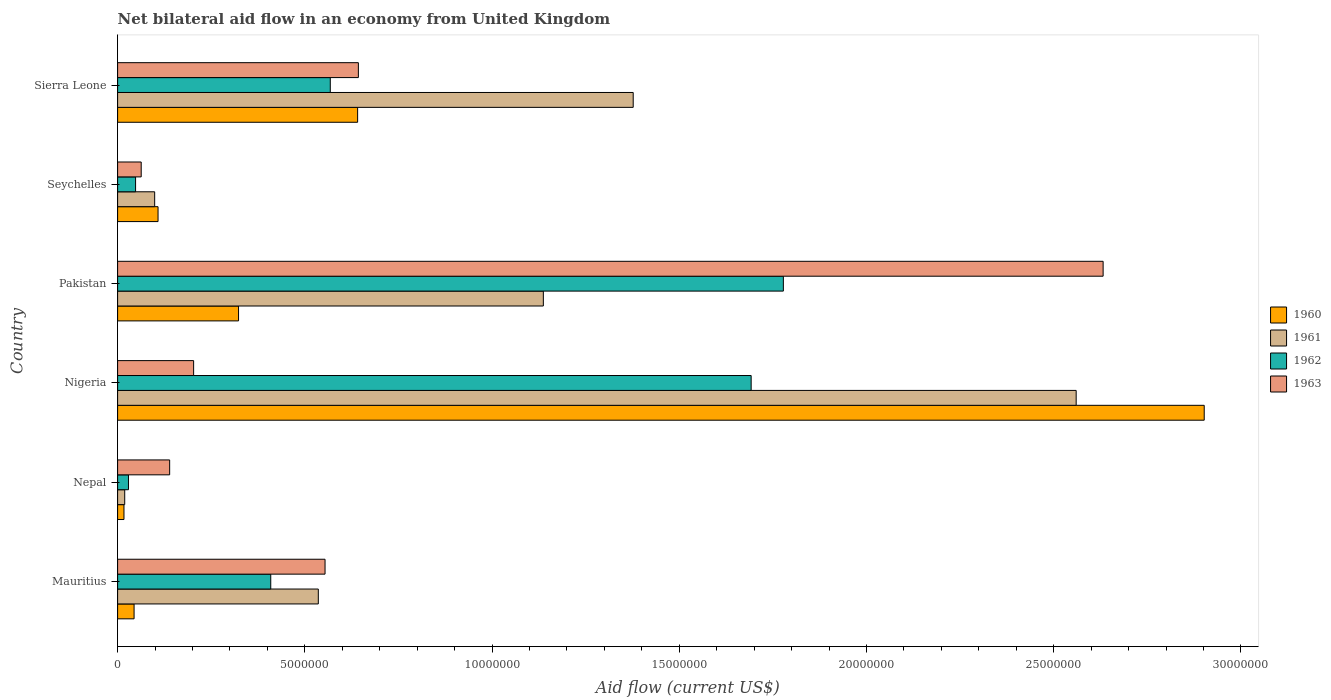Are the number of bars per tick equal to the number of legend labels?
Your answer should be compact. Yes. How many bars are there on the 3rd tick from the top?
Offer a terse response. 4. What is the label of the 2nd group of bars from the top?
Your response must be concise. Seychelles. Across all countries, what is the maximum net bilateral aid flow in 1962?
Keep it short and to the point. 1.78e+07. In which country was the net bilateral aid flow in 1962 maximum?
Provide a succinct answer. Pakistan. In which country was the net bilateral aid flow in 1962 minimum?
Your answer should be very brief. Nepal. What is the total net bilateral aid flow in 1961 in the graph?
Ensure brevity in your answer.  5.73e+07. What is the difference between the net bilateral aid flow in 1963 in Nigeria and that in Seychelles?
Provide a succinct answer. 1.40e+06. What is the difference between the net bilateral aid flow in 1962 in Sierra Leone and the net bilateral aid flow in 1963 in Pakistan?
Offer a terse response. -2.06e+07. What is the average net bilateral aid flow in 1963 per country?
Your answer should be very brief. 7.06e+06. What is the difference between the net bilateral aid flow in 1962 and net bilateral aid flow in 1963 in Pakistan?
Offer a very short reply. -8.54e+06. In how many countries, is the net bilateral aid flow in 1960 greater than 25000000 US$?
Offer a very short reply. 1. What is the ratio of the net bilateral aid flow in 1960 in Pakistan to that in Seychelles?
Keep it short and to the point. 2.99. Is the difference between the net bilateral aid flow in 1962 in Nepal and Pakistan greater than the difference between the net bilateral aid flow in 1963 in Nepal and Pakistan?
Provide a succinct answer. Yes. What is the difference between the highest and the second highest net bilateral aid flow in 1963?
Keep it short and to the point. 1.99e+07. What is the difference between the highest and the lowest net bilateral aid flow in 1962?
Ensure brevity in your answer.  1.75e+07. Is the sum of the net bilateral aid flow in 1960 in Nepal and Seychelles greater than the maximum net bilateral aid flow in 1961 across all countries?
Your answer should be very brief. No. Is it the case that in every country, the sum of the net bilateral aid flow in 1961 and net bilateral aid flow in 1962 is greater than the sum of net bilateral aid flow in 1960 and net bilateral aid flow in 1963?
Keep it short and to the point. No. What does the 3rd bar from the bottom in Sierra Leone represents?
Your answer should be very brief. 1962. Is it the case that in every country, the sum of the net bilateral aid flow in 1960 and net bilateral aid flow in 1961 is greater than the net bilateral aid flow in 1962?
Provide a short and direct response. No. How many bars are there?
Make the answer very short. 24. Are the values on the major ticks of X-axis written in scientific E-notation?
Provide a succinct answer. No. Does the graph contain any zero values?
Make the answer very short. No. Does the graph contain grids?
Provide a succinct answer. No. Where does the legend appear in the graph?
Your answer should be compact. Center right. How many legend labels are there?
Offer a terse response. 4. How are the legend labels stacked?
Your answer should be compact. Vertical. What is the title of the graph?
Your response must be concise. Net bilateral aid flow in an economy from United Kingdom. What is the Aid flow (current US$) in 1961 in Mauritius?
Your response must be concise. 5.36e+06. What is the Aid flow (current US$) in 1962 in Mauritius?
Your answer should be compact. 4.09e+06. What is the Aid flow (current US$) in 1963 in Mauritius?
Provide a succinct answer. 5.54e+06. What is the Aid flow (current US$) of 1961 in Nepal?
Your answer should be compact. 1.90e+05. What is the Aid flow (current US$) in 1962 in Nepal?
Offer a very short reply. 2.90e+05. What is the Aid flow (current US$) in 1963 in Nepal?
Give a very brief answer. 1.39e+06. What is the Aid flow (current US$) of 1960 in Nigeria?
Give a very brief answer. 2.90e+07. What is the Aid flow (current US$) of 1961 in Nigeria?
Keep it short and to the point. 2.56e+07. What is the Aid flow (current US$) in 1962 in Nigeria?
Your answer should be very brief. 1.69e+07. What is the Aid flow (current US$) in 1963 in Nigeria?
Your response must be concise. 2.03e+06. What is the Aid flow (current US$) in 1960 in Pakistan?
Your response must be concise. 3.23e+06. What is the Aid flow (current US$) of 1961 in Pakistan?
Keep it short and to the point. 1.14e+07. What is the Aid flow (current US$) of 1962 in Pakistan?
Your response must be concise. 1.78e+07. What is the Aid flow (current US$) in 1963 in Pakistan?
Ensure brevity in your answer.  2.63e+07. What is the Aid flow (current US$) in 1960 in Seychelles?
Ensure brevity in your answer.  1.08e+06. What is the Aid flow (current US$) of 1961 in Seychelles?
Provide a succinct answer. 9.90e+05. What is the Aid flow (current US$) in 1963 in Seychelles?
Your answer should be very brief. 6.30e+05. What is the Aid flow (current US$) in 1960 in Sierra Leone?
Your answer should be very brief. 6.41e+06. What is the Aid flow (current US$) of 1961 in Sierra Leone?
Provide a succinct answer. 1.38e+07. What is the Aid flow (current US$) of 1962 in Sierra Leone?
Your answer should be compact. 5.68e+06. What is the Aid flow (current US$) of 1963 in Sierra Leone?
Ensure brevity in your answer.  6.43e+06. Across all countries, what is the maximum Aid flow (current US$) of 1960?
Make the answer very short. 2.90e+07. Across all countries, what is the maximum Aid flow (current US$) of 1961?
Keep it short and to the point. 2.56e+07. Across all countries, what is the maximum Aid flow (current US$) in 1962?
Ensure brevity in your answer.  1.78e+07. Across all countries, what is the maximum Aid flow (current US$) in 1963?
Your answer should be compact. 2.63e+07. Across all countries, what is the minimum Aid flow (current US$) in 1961?
Make the answer very short. 1.90e+05. Across all countries, what is the minimum Aid flow (current US$) in 1962?
Offer a terse response. 2.90e+05. Across all countries, what is the minimum Aid flow (current US$) in 1963?
Keep it short and to the point. 6.30e+05. What is the total Aid flow (current US$) in 1960 in the graph?
Your answer should be very brief. 4.04e+07. What is the total Aid flow (current US$) in 1961 in the graph?
Make the answer very short. 5.73e+07. What is the total Aid flow (current US$) in 1962 in the graph?
Offer a very short reply. 4.52e+07. What is the total Aid flow (current US$) of 1963 in the graph?
Ensure brevity in your answer.  4.23e+07. What is the difference between the Aid flow (current US$) of 1960 in Mauritius and that in Nepal?
Provide a succinct answer. 2.70e+05. What is the difference between the Aid flow (current US$) of 1961 in Mauritius and that in Nepal?
Your answer should be very brief. 5.17e+06. What is the difference between the Aid flow (current US$) in 1962 in Mauritius and that in Nepal?
Ensure brevity in your answer.  3.80e+06. What is the difference between the Aid flow (current US$) of 1963 in Mauritius and that in Nepal?
Make the answer very short. 4.15e+06. What is the difference between the Aid flow (current US$) of 1960 in Mauritius and that in Nigeria?
Your answer should be compact. -2.86e+07. What is the difference between the Aid flow (current US$) of 1961 in Mauritius and that in Nigeria?
Provide a short and direct response. -2.02e+07. What is the difference between the Aid flow (current US$) in 1962 in Mauritius and that in Nigeria?
Give a very brief answer. -1.28e+07. What is the difference between the Aid flow (current US$) of 1963 in Mauritius and that in Nigeria?
Keep it short and to the point. 3.51e+06. What is the difference between the Aid flow (current US$) in 1960 in Mauritius and that in Pakistan?
Your answer should be compact. -2.79e+06. What is the difference between the Aid flow (current US$) in 1961 in Mauritius and that in Pakistan?
Your answer should be very brief. -6.01e+06. What is the difference between the Aid flow (current US$) of 1962 in Mauritius and that in Pakistan?
Make the answer very short. -1.37e+07. What is the difference between the Aid flow (current US$) of 1963 in Mauritius and that in Pakistan?
Your response must be concise. -2.08e+07. What is the difference between the Aid flow (current US$) in 1960 in Mauritius and that in Seychelles?
Provide a short and direct response. -6.40e+05. What is the difference between the Aid flow (current US$) in 1961 in Mauritius and that in Seychelles?
Ensure brevity in your answer.  4.37e+06. What is the difference between the Aid flow (current US$) in 1962 in Mauritius and that in Seychelles?
Keep it short and to the point. 3.61e+06. What is the difference between the Aid flow (current US$) in 1963 in Mauritius and that in Seychelles?
Make the answer very short. 4.91e+06. What is the difference between the Aid flow (current US$) in 1960 in Mauritius and that in Sierra Leone?
Your response must be concise. -5.97e+06. What is the difference between the Aid flow (current US$) in 1961 in Mauritius and that in Sierra Leone?
Your response must be concise. -8.41e+06. What is the difference between the Aid flow (current US$) of 1962 in Mauritius and that in Sierra Leone?
Your response must be concise. -1.59e+06. What is the difference between the Aid flow (current US$) in 1963 in Mauritius and that in Sierra Leone?
Offer a terse response. -8.90e+05. What is the difference between the Aid flow (current US$) in 1960 in Nepal and that in Nigeria?
Your response must be concise. -2.88e+07. What is the difference between the Aid flow (current US$) in 1961 in Nepal and that in Nigeria?
Ensure brevity in your answer.  -2.54e+07. What is the difference between the Aid flow (current US$) in 1962 in Nepal and that in Nigeria?
Keep it short and to the point. -1.66e+07. What is the difference between the Aid flow (current US$) in 1963 in Nepal and that in Nigeria?
Your answer should be very brief. -6.40e+05. What is the difference between the Aid flow (current US$) in 1960 in Nepal and that in Pakistan?
Give a very brief answer. -3.06e+06. What is the difference between the Aid flow (current US$) of 1961 in Nepal and that in Pakistan?
Keep it short and to the point. -1.12e+07. What is the difference between the Aid flow (current US$) of 1962 in Nepal and that in Pakistan?
Offer a terse response. -1.75e+07. What is the difference between the Aid flow (current US$) in 1963 in Nepal and that in Pakistan?
Provide a succinct answer. -2.49e+07. What is the difference between the Aid flow (current US$) in 1960 in Nepal and that in Seychelles?
Keep it short and to the point. -9.10e+05. What is the difference between the Aid flow (current US$) of 1961 in Nepal and that in Seychelles?
Offer a very short reply. -8.00e+05. What is the difference between the Aid flow (current US$) of 1962 in Nepal and that in Seychelles?
Your answer should be compact. -1.90e+05. What is the difference between the Aid flow (current US$) of 1963 in Nepal and that in Seychelles?
Provide a succinct answer. 7.60e+05. What is the difference between the Aid flow (current US$) in 1960 in Nepal and that in Sierra Leone?
Keep it short and to the point. -6.24e+06. What is the difference between the Aid flow (current US$) of 1961 in Nepal and that in Sierra Leone?
Provide a succinct answer. -1.36e+07. What is the difference between the Aid flow (current US$) in 1962 in Nepal and that in Sierra Leone?
Your response must be concise. -5.39e+06. What is the difference between the Aid flow (current US$) of 1963 in Nepal and that in Sierra Leone?
Make the answer very short. -5.04e+06. What is the difference between the Aid flow (current US$) in 1960 in Nigeria and that in Pakistan?
Ensure brevity in your answer.  2.58e+07. What is the difference between the Aid flow (current US$) of 1961 in Nigeria and that in Pakistan?
Offer a very short reply. 1.42e+07. What is the difference between the Aid flow (current US$) of 1962 in Nigeria and that in Pakistan?
Provide a short and direct response. -8.60e+05. What is the difference between the Aid flow (current US$) of 1963 in Nigeria and that in Pakistan?
Ensure brevity in your answer.  -2.43e+07. What is the difference between the Aid flow (current US$) in 1960 in Nigeria and that in Seychelles?
Ensure brevity in your answer.  2.79e+07. What is the difference between the Aid flow (current US$) in 1961 in Nigeria and that in Seychelles?
Keep it short and to the point. 2.46e+07. What is the difference between the Aid flow (current US$) of 1962 in Nigeria and that in Seychelles?
Your answer should be compact. 1.64e+07. What is the difference between the Aid flow (current US$) in 1963 in Nigeria and that in Seychelles?
Your answer should be compact. 1.40e+06. What is the difference between the Aid flow (current US$) in 1960 in Nigeria and that in Sierra Leone?
Your response must be concise. 2.26e+07. What is the difference between the Aid flow (current US$) of 1961 in Nigeria and that in Sierra Leone?
Give a very brief answer. 1.18e+07. What is the difference between the Aid flow (current US$) of 1962 in Nigeria and that in Sierra Leone?
Your answer should be compact. 1.12e+07. What is the difference between the Aid flow (current US$) in 1963 in Nigeria and that in Sierra Leone?
Offer a terse response. -4.40e+06. What is the difference between the Aid flow (current US$) in 1960 in Pakistan and that in Seychelles?
Give a very brief answer. 2.15e+06. What is the difference between the Aid flow (current US$) of 1961 in Pakistan and that in Seychelles?
Give a very brief answer. 1.04e+07. What is the difference between the Aid flow (current US$) of 1962 in Pakistan and that in Seychelles?
Ensure brevity in your answer.  1.73e+07. What is the difference between the Aid flow (current US$) in 1963 in Pakistan and that in Seychelles?
Provide a short and direct response. 2.57e+07. What is the difference between the Aid flow (current US$) of 1960 in Pakistan and that in Sierra Leone?
Give a very brief answer. -3.18e+06. What is the difference between the Aid flow (current US$) of 1961 in Pakistan and that in Sierra Leone?
Offer a terse response. -2.40e+06. What is the difference between the Aid flow (current US$) of 1962 in Pakistan and that in Sierra Leone?
Provide a short and direct response. 1.21e+07. What is the difference between the Aid flow (current US$) of 1963 in Pakistan and that in Sierra Leone?
Provide a succinct answer. 1.99e+07. What is the difference between the Aid flow (current US$) in 1960 in Seychelles and that in Sierra Leone?
Make the answer very short. -5.33e+06. What is the difference between the Aid flow (current US$) in 1961 in Seychelles and that in Sierra Leone?
Your answer should be very brief. -1.28e+07. What is the difference between the Aid flow (current US$) in 1962 in Seychelles and that in Sierra Leone?
Keep it short and to the point. -5.20e+06. What is the difference between the Aid flow (current US$) in 1963 in Seychelles and that in Sierra Leone?
Keep it short and to the point. -5.80e+06. What is the difference between the Aid flow (current US$) in 1960 in Mauritius and the Aid flow (current US$) in 1963 in Nepal?
Provide a succinct answer. -9.50e+05. What is the difference between the Aid flow (current US$) of 1961 in Mauritius and the Aid flow (current US$) of 1962 in Nepal?
Your answer should be very brief. 5.07e+06. What is the difference between the Aid flow (current US$) in 1961 in Mauritius and the Aid flow (current US$) in 1963 in Nepal?
Offer a terse response. 3.97e+06. What is the difference between the Aid flow (current US$) of 1962 in Mauritius and the Aid flow (current US$) of 1963 in Nepal?
Your answer should be compact. 2.70e+06. What is the difference between the Aid flow (current US$) in 1960 in Mauritius and the Aid flow (current US$) in 1961 in Nigeria?
Offer a terse response. -2.52e+07. What is the difference between the Aid flow (current US$) in 1960 in Mauritius and the Aid flow (current US$) in 1962 in Nigeria?
Offer a terse response. -1.65e+07. What is the difference between the Aid flow (current US$) in 1960 in Mauritius and the Aid flow (current US$) in 1963 in Nigeria?
Keep it short and to the point. -1.59e+06. What is the difference between the Aid flow (current US$) of 1961 in Mauritius and the Aid flow (current US$) of 1962 in Nigeria?
Offer a terse response. -1.16e+07. What is the difference between the Aid flow (current US$) of 1961 in Mauritius and the Aid flow (current US$) of 1963 in Nigeria?
Offer a terse response. 3.33e+06. What is the difference between the Aid flow (current US$) in 1962 in Mauritius and the Aid flow (current US$) in 1963 in Nigeria?
Provide a short and direct response. 2.06e+06. What is the difference between the Aid flow (current US$) in 1960 in Mauritius and the Aid flow (current US$) in 1961 in Pakistan?
Your answer should be compact. -1.09e+07. What is the difference between the Aid flow (current US$) in 1960 in Mauritius and the Aid flow (current US$) in 1962 in Pakistan?
Offer a very short reply. -1.73e+07. What is the difference between the Aid flow (current US$) in 1960 in Mauritius and the Aid flow (current US$) in 1963 in Pakistan?
Your answer should be compact. -2.59e+07. What is the difference between the Aid flow (current US$) of 1961 in Mauritius and the Aid flow (current US$) of 1962 in Pakistan?
Keep it short and to the point. -1.24e+07. What is the difference between the Aid flow (current US$) of 1961 in Mauritius and the Aid flow (current US$) of 1963 in Pakistan?
Provide a short and direct response. -2.10e+07. What is the difference between the Aid flow (current US$) in 1962 in Mauritius and the Aid flow (current US$) in 1963 in Pakistan?
Your response must be concise. -2.22e+07. What is the difference between the Aid flow (current US$) in 1960 in Mauritius and the Aid flow (current US$) in 1961 in Seychelles?
Provide a succinct answer. -5.50e+05. What is the difference between the Aid flow (current US$) of 1960 in Mauritius and the Aid flow (current US$) of 1962 in Seychelles?
Offer a terse response. -4.00e+04. What is the difference between the Aid flow (current US$) of 1960 in Mauritius and the Aid flow (current US$) of 1963 in Seychelles?
Your response must be concise. -1.90e+05. What is the difference between the Aid flow (current US$) of 1961 in Mauritius and the Aid flow (current US$) of 1962 in Seychelles?
Offer a very short reply. 4.88e+06. What is the difference between the Aid flow (current US$) in 1961 in Mauritius and the Aid flow (current US$) in 1963 in Seychelles?
Make the answer very short. 4.73e+06. What is the difference between the Aid flow (current US$) in 1962 in Mauritius and the Aid flow (current US$) in 1963 in Seychelles?
Ensure brevity in your answer.  3.46e+06. What is the difference between the Aid flow (current US$) of 1960 in Mauritius and the Aid flow (current US$) of 1961 in Sierra Leone?
Give a very brief answer. -1.33e+07. What is the difference between the Aid flow (current US$) in 1960 in Mauritius and the Aid flow (current US$) in 1962 in Sierra Leone?
Keep it short and to the point. -5.24e+06. What is the difference between the Aid flow (current US$) in 1960 in Mauritius and the Aid flow (current US$) in 1963 in Sierra Leone?
Give a very brief answer. -5.99e+06. What is the difference between the Aid flow (current US$) of 1961 in Mauritius and the Aid flow (current US$) of 1962 in Sierra Leone?
Ensure brevity in your answer.  -3.20e+05. What is the difference between the Aid flow (current US$) of 1961 in Mauritius and the Aid flow (current US$) of 1963 in Sierra Leone?
Ensure brevity in your answer.  -1.07e+06. What is the difference between the Aid flow (current US$) in 1962 in Mauritius and the Aid flow (current US$) in 1963 in Sierra Leone?
Offer a terse response. -2.34e+06. What is the difference between the Aid flow (current US$) of 1960 in Nepal and the Aid flow (current US$) of 1961 in Nigeria?
Ensure brevity in your answer.  -2.54e+07. What is the difference between the Aid flow (current US$) of 1960 in Nepal and the Aid flow (current US$) of 1962 in Nigeria?
Keep it short and to the point. -1.68e+07. What is the difference between the Aid flow (current US$) of 1960 in Nepal and the Aid flow (current US$) of 1963 in Nigeria?
Give a very brief answer. -1.86e+06. What is the difference between the Aid flow (current US$) of 1961 in Nepal and the Aid flow (current US$) of 1962 in Nigeria?
Give a very brief answer. -1.67e+07. What is the difference between the Aid flow (current US$) in 1961 in Nepal and the Aid flow (current US$) in 1963 in Nigeria?
Make the answer very short. -1.84e+06. What is the difference between the Aid flow (current US$) of 1962 in Nepal and the Aid flow (current US$) of 1963 in Nigeria?
Your answer should be compact. -1.74e+06. What is the difference between the Aid flow (current US$) in 1960 in Nepal and the Aid flow (current US$) in 1961 in Pakistan?
Provide a short and direct response. -1.12e+07. What is the difference between the Aid flow (current US$) in 1960 in Nepal and the Aid flow (current US$) in 1962 in Pakistan?
Your answer should be very brief. -1.76e+07. What is the difference between the Aid flow (current US$) of 1960 in Nepal and the Aid flow (current US$) of 1963 in Pakistan?
Offer a terse response. -2.62e+07. What is the difference between the Aid flow (current US$) of 1961 in Nepal and the Aid flow (current US$) of 1962 in Pakistan?
Your response must be concise. -1.76e+07. What is the difference between the Aid flow (current US$) in 1961 in Nepal and the Aid flow (current US$) in 1963 in Pakistan?
Give a very brief answer. -2.61e+07. What is the difference between the Aid flow (current US$) of 1962 in Nepal and the Aid flow (current US$) of 1963 in Pakistan?
Offer a very short reply. -2.60e+07. What is the difference between the Aid flow (current US$) in 1960 in Nepal and the Aid flow (current US$) in 1961 in Seychelles?
Provide a succinct answer. -8.20e+05. What is the difference between the Aid flow (current US$) in 1960 in Nepal and the Aid flow (current US$) in 1962 in Seychelles?
Your response must be concise. -3.10e+05. What is the difference between the Aid flow (current US$) in 1960 in Nepal and the Aid flow (current US$) in 1963 in Seychelles?
Provide a succinct answer. -4.60e+05. What is the difference between the Aid flow (current US$) of 1961 in Nepal and the Aid flow (current US$) of 1963 in Seychelles?
Ensure brevity in your answer.  -4.40e+05. What is the difference between the Aid flow (current US$) in 1960 in Nepal and the Aid flow (current US$) in 1961 in Sierra Leone?
Your response must be concise. -1.36e+07. What is the difference between the Aid flow (current US$) in 1960 in Nepal and the Aid flow (current US$) in 1962 in Sierra Leone?
Offer a terse response. -5.51e+06. What is the difference between the Aid flow (current US$) in 1960 in Nepal and the Aid flow (current US$) in 1963 in Sierra Leone?
Offer a terse response. -6.26e+06. What is the difference between the Aid flow (current US$) in 1961 in Nepal and the Aid flow (current US$) in 1962 in Sierra Leone?
Your answer should be very brief. -5.49e+06. What is the difference between the Aid flow (current US$) in 1961 in Nepal and the Aid flow (current US$) in 1963 in Sierra Leone?
Provide a short and direct response. -6.24e+06. What is the difference between the Aid flow (current US$) in 1962 in Nepal and the Aid flow (current US$) in 1963 in Sierra Leone?
Keep it short and to the point. -6.14e+06. What is the difference between the Aid flow (current US$) in 1960 in Nigeria and the Aid flow (current US$) in 1961 in Pakistan?
Your answer should be very brief. 1.76e+07. What is the difference between the Aid flow (current US$) of 1960 in Nigeria and the Aid flow (current US$) of 1962 in Pakistan?
Your answer should be very brief. 1.12e+07. What is the difference between the Aid flow (current US$) in 1960 in Nigeria and the Aid flow (current US$) in 1963 in Pakistan?
Your answer should be compact. 2.70e+06. What is the difference between the Aid flow (current US$) of 1961 in Nigeria and the Aid flow (current US$) of 1962 in Pakistan?
Provide a succinct answer. 7.82e+06. What is the difference between the Aid flow (current US$) in 1961 in Nigeria and the Aid flow (current US$) in 1963 in Pakistan?
Keep it short and to the point. -7.20e+05. What is the difference between the Aid flow (current US$) in 1962 in Nigeria and the Aid flow (current US$) in 1963 in Pakistan?
Provide a succinct answer. -9.40e+06. What is the difference between the Aid flow (current US$) in 1960 in Nigeria and the Aid flow (current US$) in 1961 in Seychelles?
Offer a very short reply. 2.80e+07. What is the difference between the Aid flow (current US$) in 1960 in Nigeria and the Aid flow (current US$) in 1962 in Seychelles?
Ensure brevity in your answer.  2.85e+07. What is the difference between the Aid flow (current US$) of 1960 in Nigeria and the Aid flow (current US$) of 1963 in Seychelles?
Your response must be concise. 2.84e+07. What is the difference between the Aid flow (current US$) of 1961 in Nigeria and the Aid flow (current US$) of 1962 in Seychelles?
Give a very brief answer. 2.51e+07. What is the difference between the Aid flow (current US$) in 1961 in Nigeria and the Aid flow (current US$) in 1963 in Seychelles?
Provide a succinct answer. 2.50e+07. What is the difference between the Aid flow (current US$) in 1962 in Nigeria and the Aid flow (current US$) in 1963 in Seychelles?
Your answer should be very brief. 1.63e+07. What is the difference between the Aid flow (current US$) of 1960 in Nigeria and the Aid flow (current US$) of 1961 in Sierra Leone?
Provide a succinct answer. 1.52e+07. What is the difference between the Aid flow (current US$) in 1960 in Nigeria and the Aid flow (current US$) in 1962 in Sierra Leone?
Ensure brevity in your answer.  2.33e+07. What is the difference between the Aid flow (current US$) in 1960 in Nigeria and the Aid flow (current US$) in 1963 in Sierra Leone?
Give a very brief answer. 2.26e+07. What is the difference between the Aid flow (current US$) in 1961 in Nigeria and the Aid flow (current US$) in 1962 in Sierra Leone?
Provide a short and direct response. 1.99e+07. What is the difference between the Aid flow (current US$) in 1961 in Nigeria and the Aid flow (current US$) in 1963 in Sierra Leone?
Your answer should be compact. 1.92e+07. What is the difference between the Aid flow (current US$) in 1962 in Nigeria and the Aid flow (current US$) in 1963 in Sierra Leone?
Your answer should be compact. 1.05e+07. What is the difference between the Aid flow (current US$) of 1960 in Pakistan and the Aid flow (current US$) of 1961 in Seychelles?
Offer a very short reply. 2.24e+06. What is the difference between the Aid flow (current US$) of 1960 in Pakistan and the Aid flow (current US$) of 1962 in Seychelles?
Provide a succinct answer. 2.75e+06. What is the difference between the Aid flow (current US$) in 1960 in Pakistan and the Aid flow (current US$) in 1963 in Seychelles?
Offer a terse response. 2.60e+06. What is the difference between the Aid flow (current US$) of 1961 in Pakistan and the Aid flow (current US$) of 1962 in Seychelles?
Keep it short and to the point. 1.09e+07. What is the difference between the Aid flow (current US$) of 1961 in Pakistan and the Aid flow (current US$) of 1963 in Seychelles?
Ensure brevity in your answer.  1.07e+07. What is the difference between the Aid flow (current US$) in 1962 in Pakistan and the Aid flow (current US$) in 1963 in Seychelles?
Provide a succinct answer. 1.72e+07. What is the difference between the Aid flow (current US$) in 1960 in Pakistan and the Aid flow (current US$) in 1961 in Sierra Leone?
Offer a terse response. -1.05e+07. What is the difference between the Aid flow (current US$) of 1960 in Pakistan and the Aid flow (current US$) of 1962 in Sierra Leone?
Give a very brief answer. -2.45e+06. What is the difference between the Aid flow (current US$) in 1960 in Pakistan and the Aid flow (current US$) in 1963 in Sierra Leone?
Your answer should be compact. -3.20e+06. What is the difference between the Aid flow (current US$) of 1961 in Pakistan and the Aid flow (current US$) of 1962 in Sierra Leone?
Your answer should be very brief. 5.69e+06. What is the difference between the Aid flow (current US$) of 1961 in Pakistan and the Aid flow (current US$) of 1963 in Sierra Leone?
Offer a very short reply. 4.94e+06. What is the difference between the Aid flow (current US$) of 1962 in Pakistan and the Aid flow (current US$) of 1963 in Sierra Leone?
Ensure brevity in your answer.  1.14e+07. What is the difference between the Aid flow (current US$) of 1960 in Seychelles and the Aid flow (current US$) of 1961 in Sierra Leone?
Your response must be concise. -1.27e+07. What is the difference between the Aid flow (current US$) in 1960 in Seychelles and the Aid flow (current US$) in 1962 in Sierra Leone?
Provide a short and direct response. -4.60e+06. What is the difference between the Aid flow (current US$) in 1960 in Seychelles and the Aid flow (current US$) in 1963 in Sierra Leone?
Your answer should be compact. -5.35e+06. What is the difference between the Aid flow (current US$) of 1961 in Seychelles and the Aid flow (current US$) of 1962 in Sierra Leone?
Offer a terse response. -4.69e+06. What is the difference between the Aid flow (current US$) of 1961 in Seychelles and the Aid flow (current US$) of 1963 in Sierra Leone?
Your answer should be compact. -5.44e+06. What is the difference between the Aid flow (current US$) of 1962 in Seychelles and the Aid flow (current US$) of 1963 in Sierra Leone?
Offer a terse response. -5.95e+06. What is the average Aid flow (current US$) of 1960 per country?
Keep it short and to the point. 6.72e+06. What is the average Aid flow (current US$) in 1961 per country?
Provide a succinct answer. 9.55e+06. What is the average Aid flow (current US$) in 1962 per country?
Ensure brevity in your answer.  7.54e+06. What is the average Aid flow (current US$) in 1963 per country?
Provide a short and direct response. 7.06e+06. What is the difference between the Aid flow (current US$) in 1960 and Aid flow (current US$) in 1961 in Mauritius?
Keep it short and to the point. -4.92e+06. What is the difference between the Aid flow (current US$) in 1960 and Aid flow (current US$) in 1962 in Mauritius?
Offer a terse response. -3.65e+06. What is the difference between the Aid flow (current US$) of 1960 and Aid flow (current US$) of 1963 in Mauritius?
Provide a succinct answer. -5.10e+06. What is the difference between the Aid flow (current US$) in 1961 and Aid flow (current US$) in 1962 in Mauritius?
Ensure brevity in your answer.  1.27e+06. What is the difference between the Aid flow (current US$) in 1962 and Aid flow (current US$) in 1963 in Mauritius?
Ensure brevity in your answer.  -1.45e+06. What is the difference between the Aid flow (current US$) in 1960 and Aid flow (current US$) in 1961 in Nepal?
Keep it short and to the point. -2.00e+04. What is the difference between the Aid flow (current US$) of 1960 and Aid flow (current US$) of 1962 in Nepal?
Provide a short and direct response. -1.20e+05. What is the difference between the Aid flow (current US$) in 1960 and Aid flow (current US$) in 1963 in Nepal?
Ensure brevity in your answer.  -1.22e+06. What is the difference between the Aid flow (current US$) in 1961 and Aid flow (current US$) in 1963 in Nepal?
Make the answer very short. -1.20e+06. What is the difference between the Aid flow (current US$) in 1962 and Aid flow (current US$) in 1963 in Nepal?
Your answer should be very brief. -1.10e+06. What is the difference between the Aid flow (current US$) of 1960 and Aid flow (current US$) of 1961 in Nigeria?
Offer a terse response. 3.42e+06. What is the difference between the Aid flow (current US$) of 1960 and Aid flow (current US$) of 1962 in Nigeria?
Offer a terse response. 1.21e+07. What is the difference between the Aid flow (current US$) of 1960 and Aid flow (current US$) of 1963 in Nigeria?
Make the answer very short. 2.70e+07. What is the difference between the Aid flow (current US$) of 1961 and Aid flow (current US$) of 1962 in Nigeria?
Ensure brevity in your answer.  8.68e+06. What is the difference between the Aid flow (current US$) of 1961 and Aid flow (current US$) of 1963 in Nigeria?
Keep it short and to the point. 2.36e+07. What is the difference between the Aid flow (current US$) in 1962 and Aid flow (current US$) in 1963 in Nigeria?
Give a very brief answer. 1.49e+07. What is the difference between the Aid flow (current US$) in 1960 and Aid flow (current US$) in 1961 in Pakistan?
Keep it short and to the point. -8.14e+06. What is the difference between the Aid flow (current US$) in 1960 and Aid flow (current US$) in 1962 in Pakistan?
Your answer should be very brief. -1.46e+07. What is the difference between the Aid flow (current US$) in 1960 and Aid flow (current US$) in 1963 in Pakistan?
Offer a very short reply. -2.31e+07. What is the difference between the Aid flow (current US$) of 1961 and Aid flow (current US$) of 1962 in Pakistan?
Provide a succinct answer. -6.41e+06. What is the difference between the Aid flow (current US$) in 1961 and Aid flow (current US$) in 1963 in Pakistan?
Provide a succinct answer. -1.50e+07. What is the difference between the Aid flow (current US$) in 1962 and Aid flow (current US$) in 1963 in Pakistan?
Your answer should be very brief. -8.54e+06. What is the difference between the Aid flow (current US$) in 1960 and Aid flow (current US$) in 1961 in Seychelles?
Offer a terse response. 9.00e+04. What is the difference between the Aid flow (current US$) of 1960 and Aid flow (current US$) of 1962 in Seychelles?
Give a very brief answer. 6.00e+05. What is the difference between the Aid flow (current US$) in 1960 and Aid flow (current US$) in 1963 in Seychelles?
Provide a succinct answer. 4.50e+05. What is the difference between the Aid flow (current US$) of 1961 and Aid flow (current US$) of 1962 in Seychelles?
Give a very brief answer. 5.10e+05. What is the difference between the Aid flow (current US$) of 1962 and Aid flow (current US$) of 1963 in Seychelles?
Ensure brevity in your answer.  -1.50e+05. What is the difference between the Aid flow (current US$) of 1960 and Aid flow (current US$) of 1961 in Sierra Leone?
Your answer should be very brief. -7.36e+06. What is the difference between the Aid flow (current US$) in 1960 and Aid flow (current US$) in 1962 in Sierra Leone?
Your answer should be compact. 7.30e+05. What is the difference between the Aid flow (current US$) in 1960 and Aid flow (current US$) in 1963 in Sierra Leone?
Your answer should be compact. -2.00e+04. What is the difference between the Aid flow (current US$) of 1961 and Aid flow (current US$) of 1962 in Sierra Leone?
Offer a very short reply. 8.09e+06. What is the difference between the Aid flow (current US$) in 1961 and Aid flow (current US$) in 1963 in Sierra Leone?
Your answer should be very brief. 7.34e+06. What is the difference between the Aid flow (current US$) in 1962 and Aid flow (current US$) in 1963 in Sierra Leone?
Ensure brevity in your answer.  -7.50e+05. What is the ratio of the Aid flow (current US$) in 1960 in Mauritius to that in Nepal?
Offer a very short reply. 2.59. What is the ratio of the Aid flow (current US$) of 1961 in Mauritius to that in Nepal?
Your answer should be very brief. 28.21. What is the ratio of the Aid flow (current US$) of 1962 in Mauritius to that in Nepal?
Your response must be concise. 14.1. What is the ratio of the Aid flow (current US$) of 1963 in Mauritius to that in Nepal?
Offer a very short reply. 3.99. What is the ratio of the Aid flow (current US$) in 1960 in Mauritius to that in Nigeria?
Ensure brevity in your answer.  0.02. What is the ratio of the Aid flow (current US$) of 1961 in Mauritius to that in Nigeria?
Your answer should be compact. 0.21. What is the ratio of the Aid flow (current US$) in 1962 in Mauritius to that in Nigeria?
Give a very brief answer. 0.24. What is the ratio of the Aid flow (current US$) in 1963 in Mauritius to that in Nigeria?
Your answer should be compact. 2.73. What is the ratio of the Aid flow (current US$) in 1960 in Mauritius to that in Pakistan?
Make the answer very short. 0.14. What is the ratio of the Aid flow (current US$) in 1961 in Mauritius to that in Pakistan?
Your answer should be very brief. 0.47. What is the ratio of the Aid flow (current US$) in 1962 in Mauritius to that in Pakistan?
Your answer should be compact. 0.23. What is the ratio of the Aid flow (current US$) in 1963 in Mauritius to that in Pakistan?
Offer a very short reply. 0.21. What is the ratio of the Aid flow (current US$) in 1960 in Mauritius to that in Seychelles?
Your response must be concise. 0.41. What is the ratio of the Aid flow (current US$) of 1961 in Mauritius to that in Seychelles?
Your answer should be compact. 5.41. What is the ratio of the Aid flow (current US$) of 1962 in Mauritius to that in Seychelles?
Offer a very short reply. 8.52. What is the ratio of the Aid flow (current US$) of 1963 in Mauritius to that in Seychelles?
Provide a short and direct response. 8.79. What is the ratio of the Aid flow (current US$) in 1960 in Mauritius to that in Sierra Leone?
Keep it short and to the point. 0.07. What is the ratio of the Aid flow (current US$) in 1961 in Mauritius to that in Sierra Leone?
Offer a very short reply. 0.39. What is the ratio of the Aid flow (current US$) of 1962 in Mauritius to that in Sierra Leone?
Make the answer very short. 0.72. What is the ratio of the Aid flow (current US$) in 1963 in Mauritius to that in Sierra Leone?
Give a very brief answer. 0.86. What is the ratio of the Aid flow (current US$) in 1960 in Nepal to that in Nigeria?
Provide a short and direct response. 0.01. What is the ratio of the Aid flow (current US$) in 1961 in Nepal to that in Nigeria?
Your answer should be very brief. 0.01. What is the ratio of the Aid flow (current US$) in 1962 in Nepal to that in Nigeria?
Your response must be concise. 0.02. What is the ratio of the Aid flow (current US$) in 1963 in Nepal to that in Nigeria?
Give a very brief answer. 0.68. What is the ratio of the Aid flow (current US$) in 1960 in Nepal to that in Pakistan?
Offer a very short reply. 0.05. What is the ratio of the Aid flow (current US$) in 1961 in Nepal to that in Pakistan?
Keep it short and to the point. 0.02. What is the ratio of the Aid flow (current US$) in 1962 in Nepal to that in Pakistan?
Your answer should be very brief. 0.02. What is the ratio of the Aid flow (current US$) in 1963 in Nepal to that in Pakistan?
Give a very brief answer. 0.05. What is the ratio of the Aid flow (current US$) in 1960 in Nepal to that in Seychelles?
Give a very brief answer. 0.16. What is the ratio of the Aid flow (current US$) of 1961 in Nepal to that in Seychelles?
Your response must be concise. 0.19. What is the ratio of the Aid flow (current US$) of 1962 in Nepal to that in Seychelles?
Offer a terse response. 0.6. What is the ratio of the Aid flow (current US$) of 1963 in Nepal to that in Seychelles?
Make the answer very short. 2.21. What is the ratio of the Aid flow (current US$) in 1960 in Nepal to that in Sierra Leone?
Give a very brief answer. 0.03. What is the ratio of the Aid flow (current US$) in 1961 in Nepal to that in Sierra Leone?
Offer a terse response. 0.01. What is the ratio of the Aid flow (current US$) of 1962 in Nepal to that in Sierra Leone?
Your answer should be very brief. 0.05. What is the ratio of the Aid flow (current US$) of 1963 in Nepal to that in Sierra Leone?
Ensure brevity in your answer.  0.22. What is the ratio of the Aid flow (current US$) in 1960 in Nigeria to that in Pakistan?
Your answer should be compact. 8.98. What is the ratio of the Aid flow (current US$) in 1961 in Nigeria to that in Pakistan?
Ensure brevity in your answer.  2.25. What is the ratio of the Aid flow (current US$) of 1962 in Nigeria to that in Pakistan?
Provide a short and direct response. 0.95. What is the ratio of the Aid flow (current US$) in 1963 in Nigeria to that in Pakistan?
Ensure brevity in your answer.  0.08. What is the ratio of the Aid flow (current US$) of 1960 in Nigeria to that in Seychelles?
Keep it short and to the point. 26.87. What is the ratio of the Aid flow (current US$) of 1961 in Nigeria to that in Seychelles?
Your response must be concise. 25.86. What is the ratio of the Aid flow (current US$) of 1962 in Nigeria to that in Seychelles?
Give a very brief answer. 35.25. What is the ratio of the Aid flow (current US$) in 1963 in Nigeria to that in Seychelles?
Offer a terse response. 3.22. What is the ratio of the Aid flow (current US$) of 1960 in Nigeria to that in Sierra Leone?
Provide a succinct answer. 4.53. What is the ratio of the Aid flow (current US$) of 1961 in Nigeria to that in Sierra Leone?
Give a very brief answer. 1.86. What is the ratio of the Aid flow (current US$) in 1962 in Nigeria to that in Sierra Leone?
Your answer should be compact. 2.98. What is the ratio of the Aid flow (current US$) in 1963 in Nigeria to that in Sierra Leone?
Offer a very short reply. 0.32. What is the ratio of the Aid flow (current US$) in 1960 in Pakistan to that in Seychelles?
Your response must be concise. 2.99. What is the ratio of the Aid flow (current US$) of 1961 in Pakistan to that in Seychelles?
Make the answer very short. 11.48. What is the ratio of the Aid flow (current US$) in 1962 in Pakistan to that in Seychelles?
Your answer should be compact. 37.04. What is the ratio of the Aid flow (current US$) of 1963 in Pakistan to that in Seychelles?
Offer a terse response. 41.78. What is the ratio of the Aid flow (current US$) of 1960 in Pakistan to that in Sierra Leone?
Provide a succinct answer. 0.5. What is the ratio of the Aid flow (current US$) in 1961 in Pakistan to that in Sierra Leone?
Keep it short and to the point. 0.83. What is the ratio of the Aid flow (current US$) of 1962 in Pakistan to that in Sierra Leone?
Offer a terse response. 3.13. What is the ratio of the Aid flow (current US$) of 1963 in Pakistan to that in Sierra Leone?
Make the answer very short. 4.09. What is the ratio of the Aid flow (current US$) of 1960 in Seychelles to that in Sierra Leone?
Keep it short and to the point. 0.17. What is the ratio of the Aid flow (current US$) in 1961 in Seychelles to that in Sierra Leone?
Offer a very short reply. 0.07. What is the ratio of the Aid flow (current US$) in 1962 in Seychelles to that in Sierra Leone?
Keep it short and to the point. 0.08. What is the ratio of the Aid flow (current US$) of 1963 in Seychelles to that in Sierra Leone?
Provide a succinct answer. 0.1. What is the difference between the highest and the second highest Aid flow (current US$) in 1960?
Make the answer very short. 2.26e+07. What is the difference between the highest and the second highest Aid flow (current US$) in 1961?
Your response must be concise. 1.18e+07. What is the difference between the highest and the second highest Aid flow (current US$) in 1962?
Your answer should be compact. 8.60e+05. What is the difference between the highest and the second highest Aid flow (current US$) in 1963?
Make the answer very short. 1.99e+07. What is the difference between the highest and the lowest Aid flow (current US$) in 1960?
Ensure brevity in your answer.  2.88e+07. What is the difference between the highest and the lowest Aid flow (current US$) of 1961?
Your answer should be compact. 2.54e+07. What is the difference between the highest and the lowest Aid flow (current US$) in 1962?
Make the answer very short. 1.75e+07. What is the difference between the highest and the lowest Aid flow (current US$) of 1963?
Your answer should be compact. 2.57e+07. 